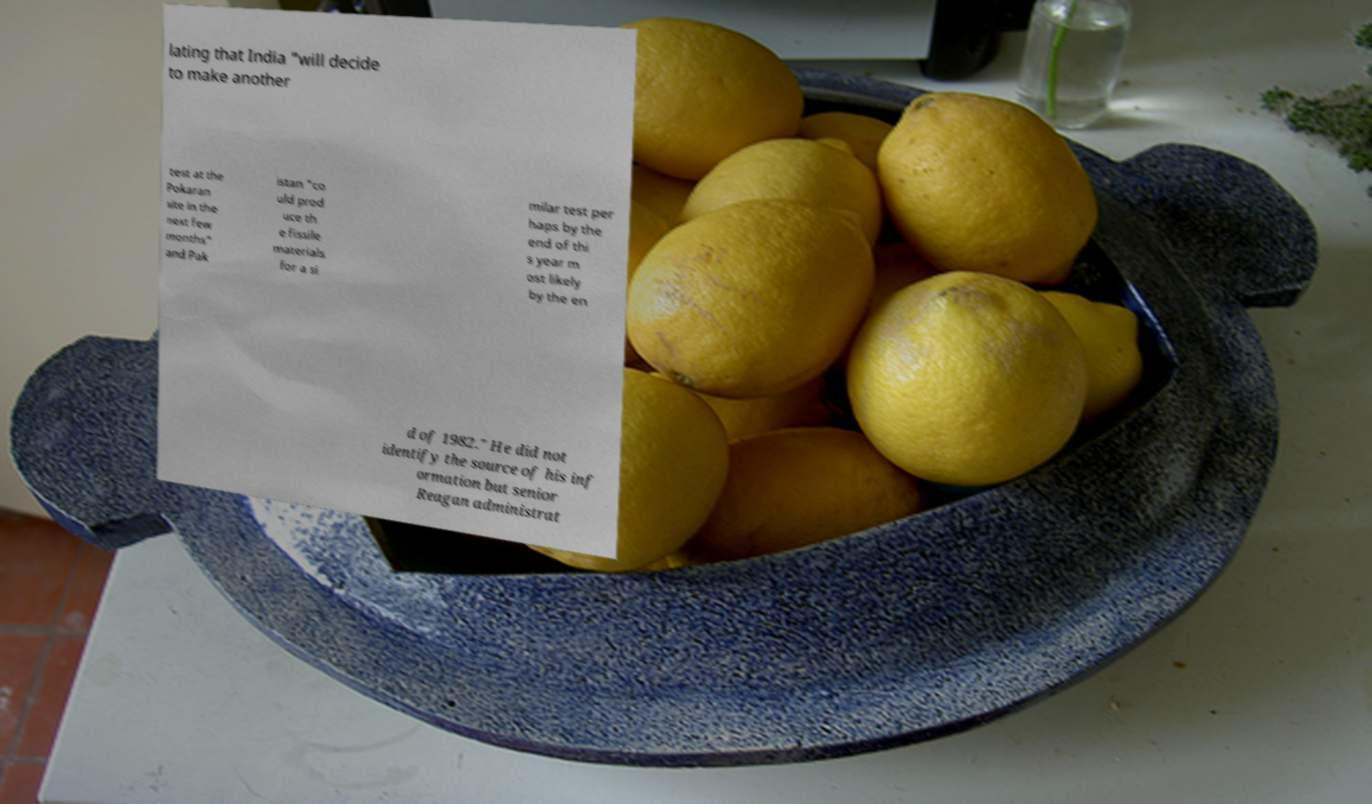Could you assist in decoding the text presented in this image and type it out clearly? lating that India "will decide to make another test at the Pokaran site in the next few months" and Pak istan "co uld prod uce th e fissile materials for a si milar test per haps by the end of thi s year m ost likely by the en d of 1982." He did not identify the source of his inf ormation but senior Reagan administrat 